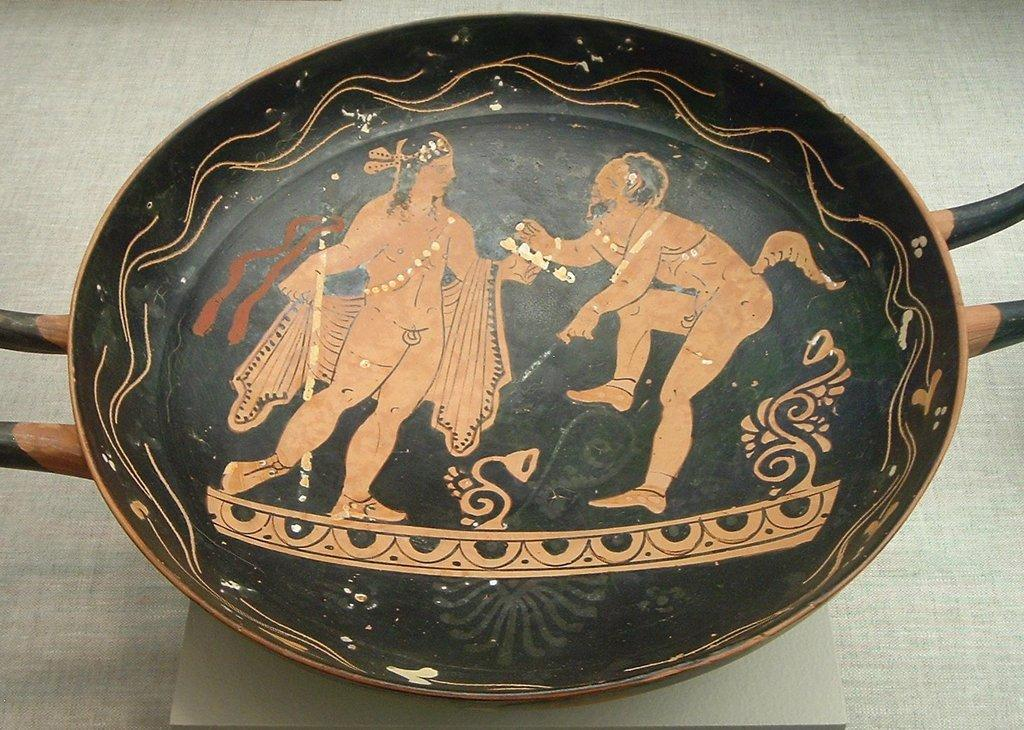What is the main subject of the image? There is a man in the image. What is the man holding in the image? The man is holding a pan. Can you describe the contents of the pan? There are two men in the pan. What is the color of the background in the image? The background of the image appears to be gray. Are the two men in the pan kissing each other in the image? There is no indication of kissing between the two men in the pan in the image. 